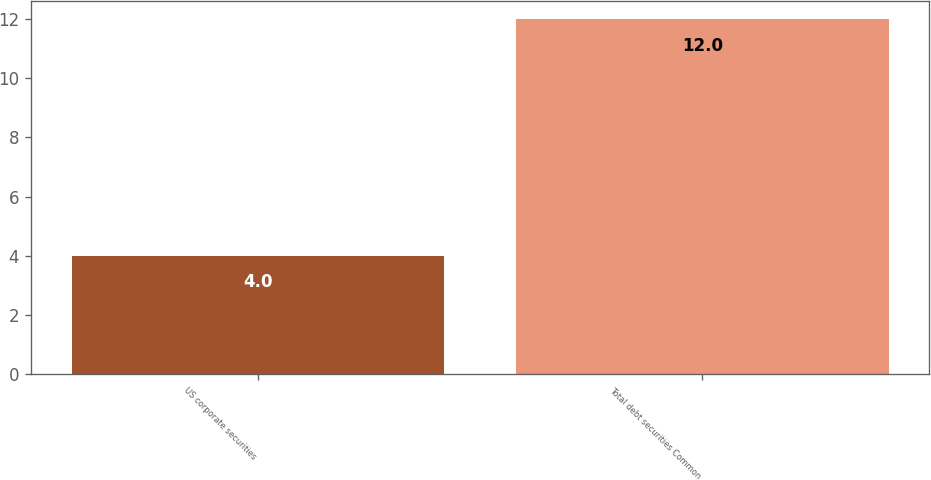Convert chart to OTSL. <chart><loc_0><loc_0><loc_500><loc_500><bar_chart><fcel>US corporate securities<fcel>Total debt securities Common<nl><fcel>4<fcel>12<nl></chart> 